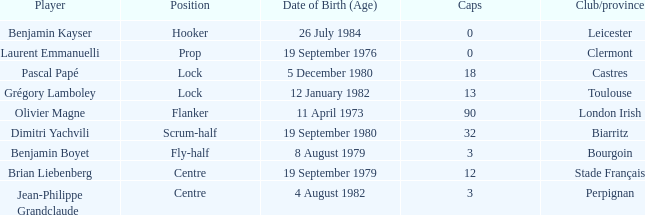Could you parse the entire table? {'header': ['Player', 'Position', 'Date of Birth (Age)', 'Caps', 'Club/province'], 'rows': [['Benjamin Kayser', 'Hooker', '26 July 1984', '0', 'Leicester'], ['Laurent Emmanuelli', 'Prop', '19 September 1976', '0', 'Clermont'], ['Pascal Papé', 'Lock', '5 December 1980', '18', 'Castres'], ['Grégory Lamboley', 'Lock', '12 January 1982', '13', 'Toulouse'], ['Olivier Magne', 'Flanker', '11 April 1973', '90', 'London Irish'], ['Dimitri Yachvili', 'Scrum-half', '19 September 1980', '32', 'Biarritz'], ['Benjamin Boyet', 'Fly-half', '8 August 1979', '3', 'Bourgoin'], ['Brian Liebenberg', 'Centre', '19 September 1979', '12', 'Stade Français'], ['Jean-Philippe Grandclaude', 'Centre', '4 August 1982', '3', 'Perpignan']]} Which athlete has a cap exceeding 12 and belongs to toulouse clubs? Grégory Lamboley. 